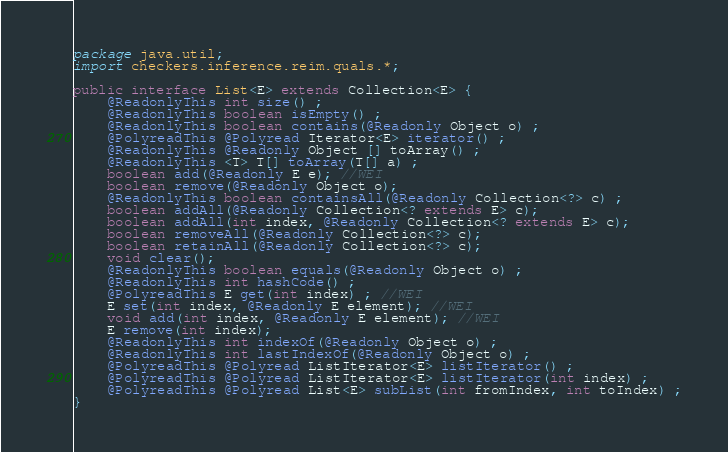Convert code to text. <code><loc_0><loc_0><loc_500><loc_500><_Java_>package java.util;
import checkers.inference.reim.quals.*;

public interface List<E> extends Collection<E> {
    @ReadonlyThis int size() ;
    @ReadonlyThis boolean isEmpty() ;
    @ReadonlyThis boolean contains(@Readonly Object o) ;
    @PolyreadThis @Polyread Iterator<E> iterator() ;
    @ReadonlyThis @Readonly Object [] toArray() ;
    @ReadonlyThis <T> T[] toArray(T[] a) ;
    boolean add(@Readonly E e); //WEI
    boolean remove(@Readonly Object o);
    @ReadonlyThis boolean containsAll(@Readonly Collection<?> c) ;
    boolean addAll(@Readonly Collection<? extends E> c);
    boolean addAll(int index, @Readonly Collection<? extends E> c);
    boolean removeAll(@Readonly Collection<?> c);
    boolean retainAll(@Readonly Collection<?> c);
    void clear();
    @ReadonlyThis boolean equals(@Readonly Object o) ;
    @ReadonlyThis int hashCode() ;
    @PolyreadThis E get(int index) ; //WEI
    E set(int index, @Readonly E element); //WEI
    void add(int index, @Readonly E element); //WEI
    E remove(int index);
    @ReadonlyThis int indexOf(@Readonly Object o) ;
    @ReadonlyThis int lastIndexOf(@Readonly Object o) ;
    @PolyreadThis @Polyread ListIterator<E> listIterator() ;
    @PolyreadThis @Polyread ListIterator<E> listIterator(int index) ;
    @PolyreadThis @Polyread List<E> subList(int fromIndex, int toIndex) ;
}
</code> 